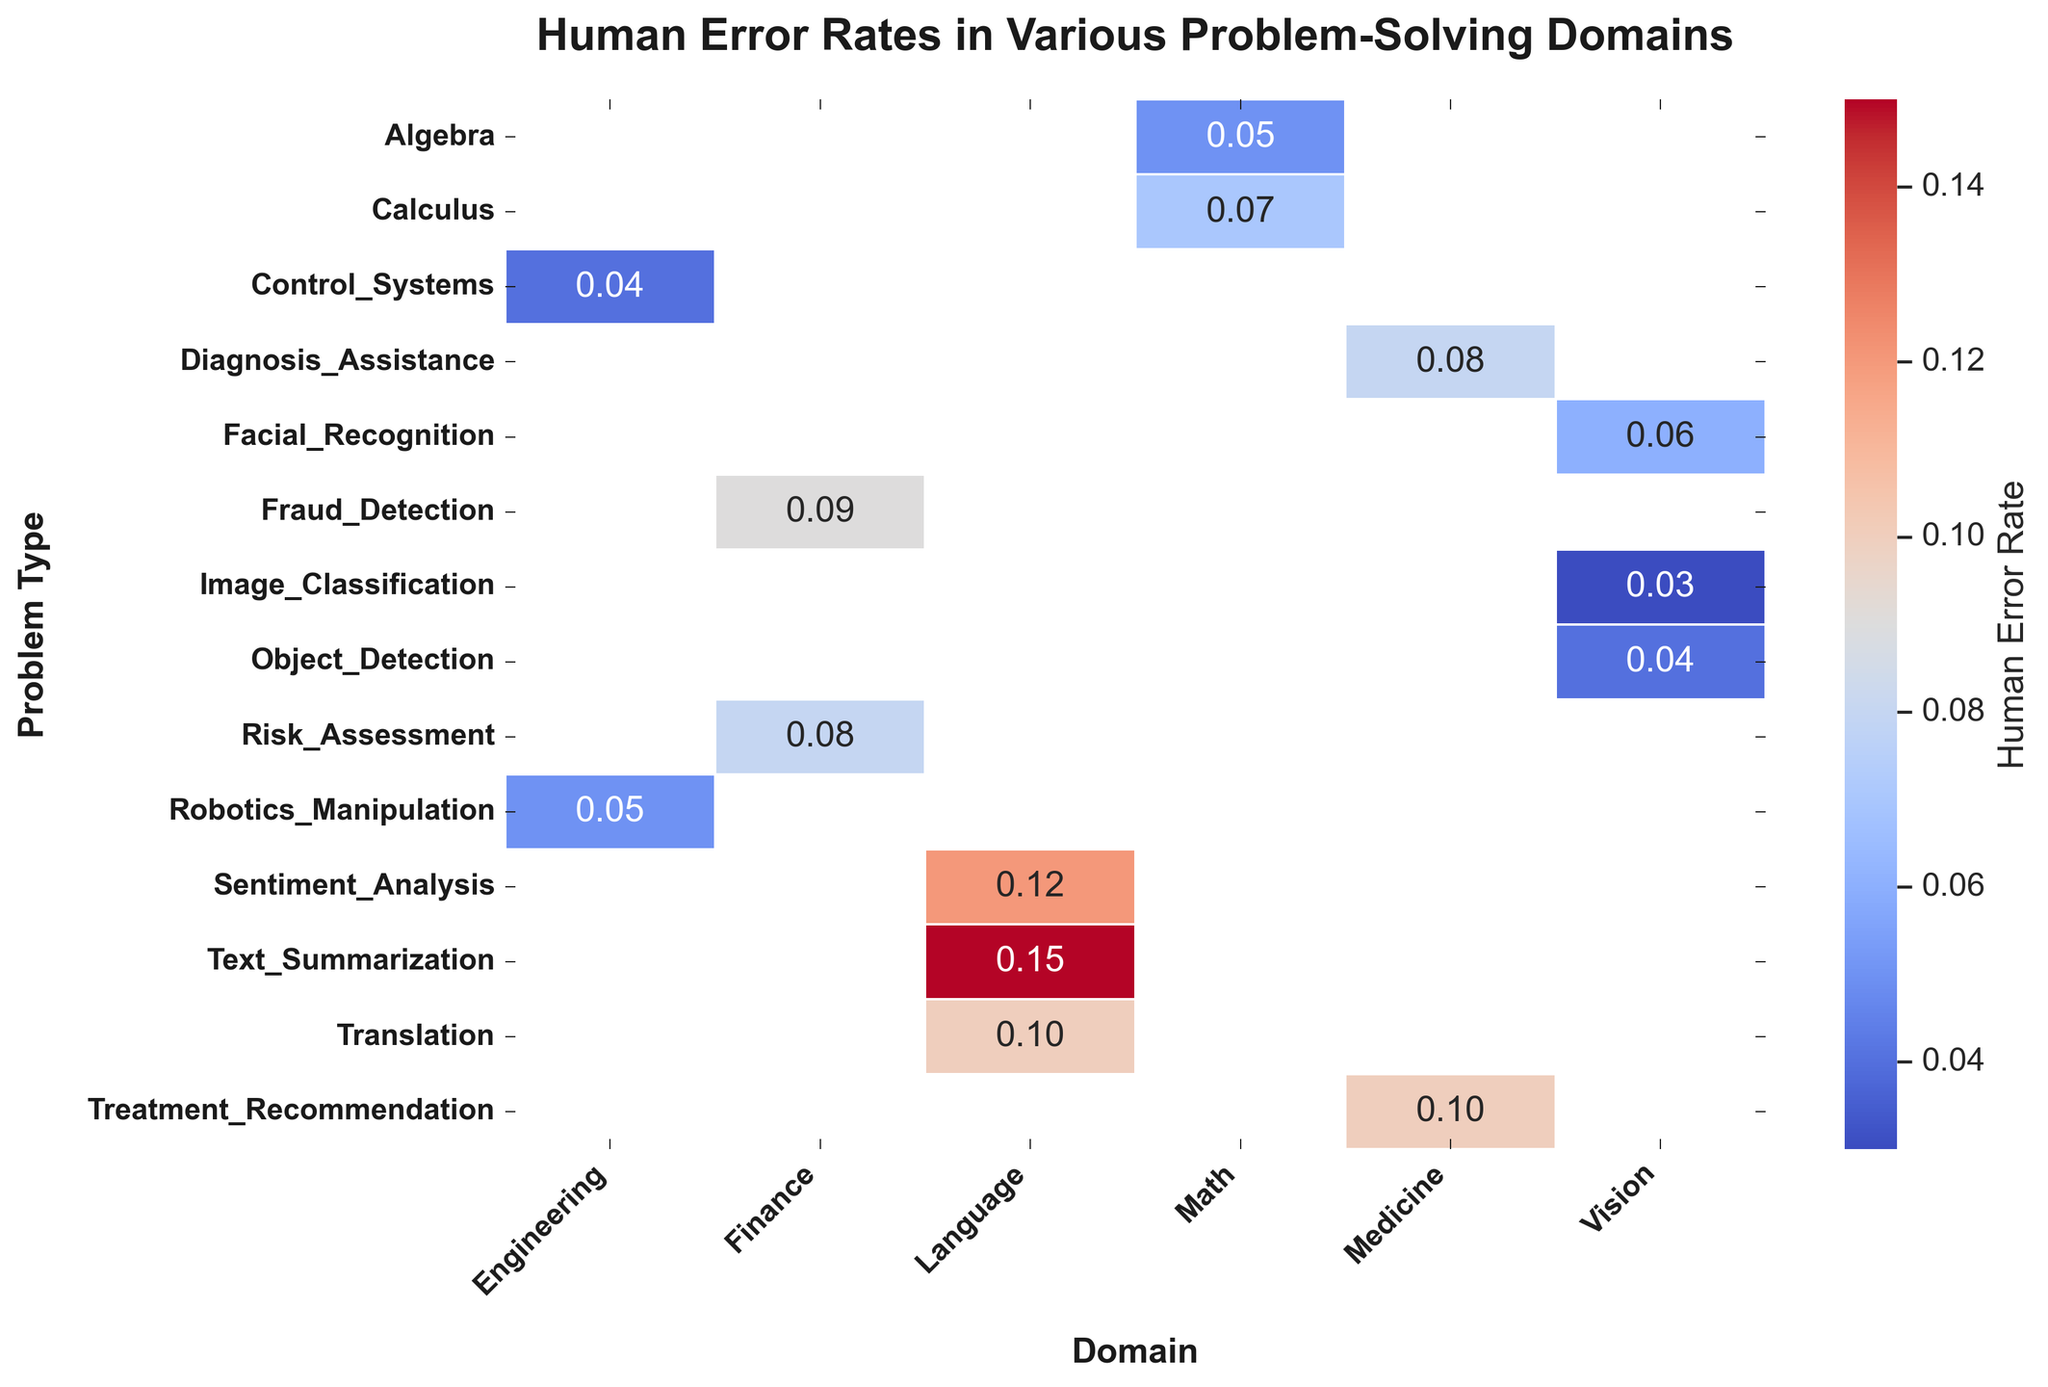What is the domain with the highest human error rate in problem-solving? To find the domain with the highest human error rate, you would scan the heatmap for the highest numerical value among the human error rates. The highest error rate is 0.15 for Text Summarization in the Language domain.
Answer: Language Which problem type in the Math domain has the lower human error rate? Within the Math domain, compare the error rates for the two problem types, Algebra and Calculus. Algebra has an error rate of 0.05, while Calculus has a slightly higher rate of 0.07. Therefore, Algebra has the lower error rate.
Answer: Algebra How does the human error rate for Image Classification in the Vision domain compare to that of Fraud Detection in the Finance domain? For a comparison, check the values for these specific problem types. The human error rate for Image Classification (Vision) is 0.03, whereas for Fraud Detection (Finance) it is 0.09. Therefore, Fraud Detection has a higher error rate compared to Image Classification.
Answer: Fraud Detection is higher Which domain has the smallest range of human error rates across its problem types? To determine the domain with the smallest range, calculate the difference between the maximum and minimum error rates for each domain. The domain Vision has human error rates ranging from 0.03 to 0.06, a difference of 0.03, which is smaller than the range in other domains.
Answer: Vision Which problem type has a higher human error rate than AI error rate in the Language domain? Look at the error rates for both humans and AI in each problem type under the Language domain. Translation has a human error rate of 0.10 and an AI error rate of 0.15, meaning the human error rate is lower. The next problem type, Text Summarization, has human and AI error rates 0.15 and 0.08 respectively; thus, it fits the criteria.
Answer: Text Summarization 